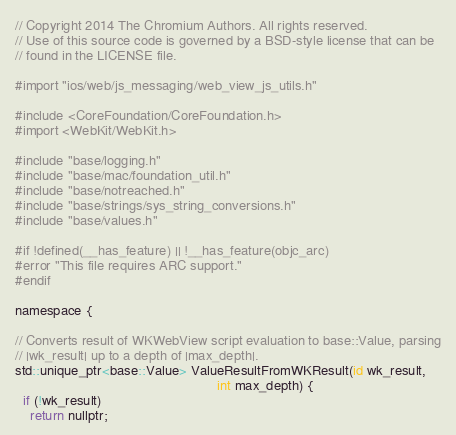<code> <loc_0><loc_0><loc_500><loc_500><_ObjectiveC_>// Copyright 2014 The Chromium Authors. All rights reserved.
// Use of this source code is governed by a BSD-style license that can be
// found in the LICENSE file.

#import "ios/web/js_messaging/web_view_js_utils.h"

#include <CoreFoundation/CoreFoundation.h>
#import <WebKit/WebKit.h>

#include "base/logging.h"
#include "base/mac/foundation_util.h"
#include "base/notreached.h"
#include "base/strings/sys_string_conversions.h"
#include "base/values.h"

#if !defined(__has_feature) || !__has_feature(objc_arc)
#error "This file requires ARC support."
#endif

namespace {

// Converts result of WKWebView script evaluation to base::Value, parsing
// |wk_result| up to a depth of |max_depth|.
std::unique_ptr<base::Value> ValueResultFromWKResult(id wk_result,
                                                     int max_depth) {
  if (!wk_result)
    return nullptr;
</code> 